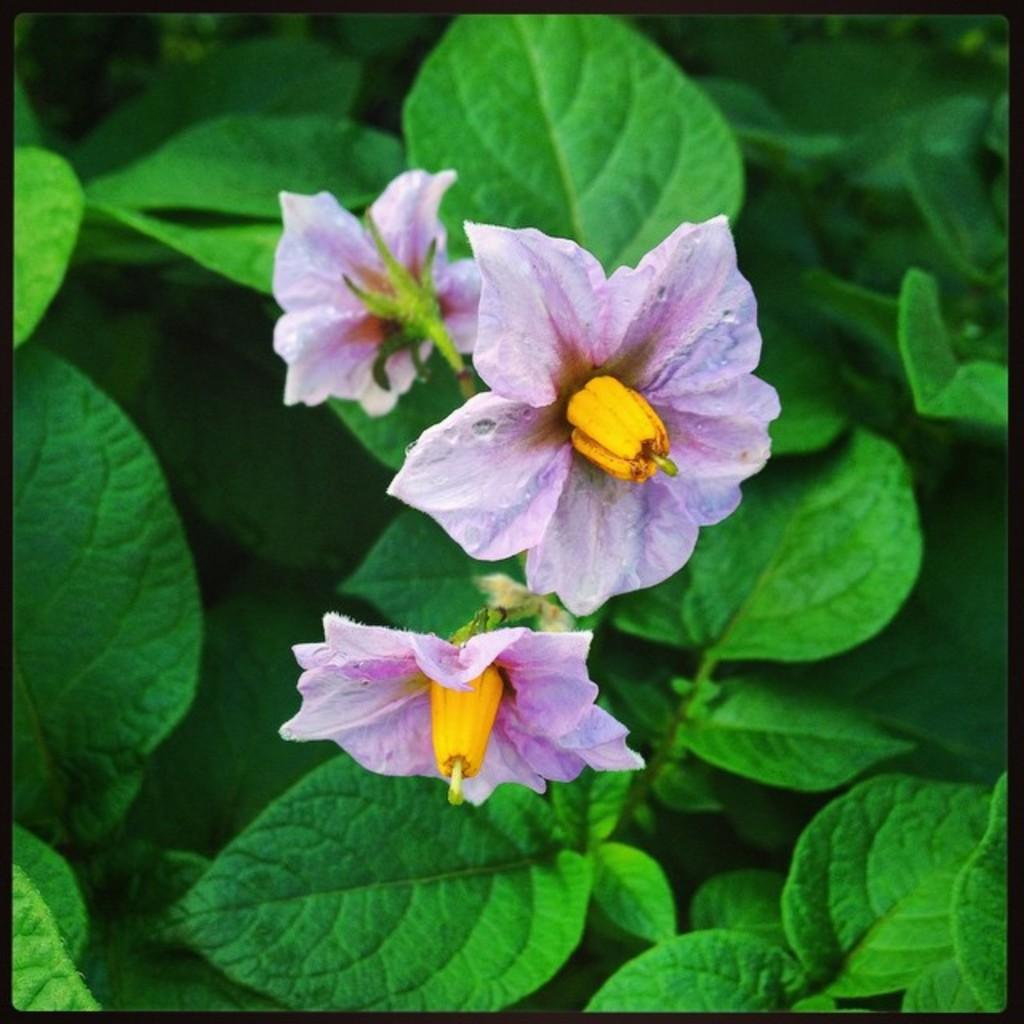What type of plants can be seen in the image? There are flowers and green leaves in the image. Can you describe the color of the flowers? The provided facts do not mention the color of the flowers. What is the color of the leaves in the image? The leaves in the image are green. What type of powder is sprinkled on the flowers in the image? There is no powder present in the image; it only features flowers and green leaves. 